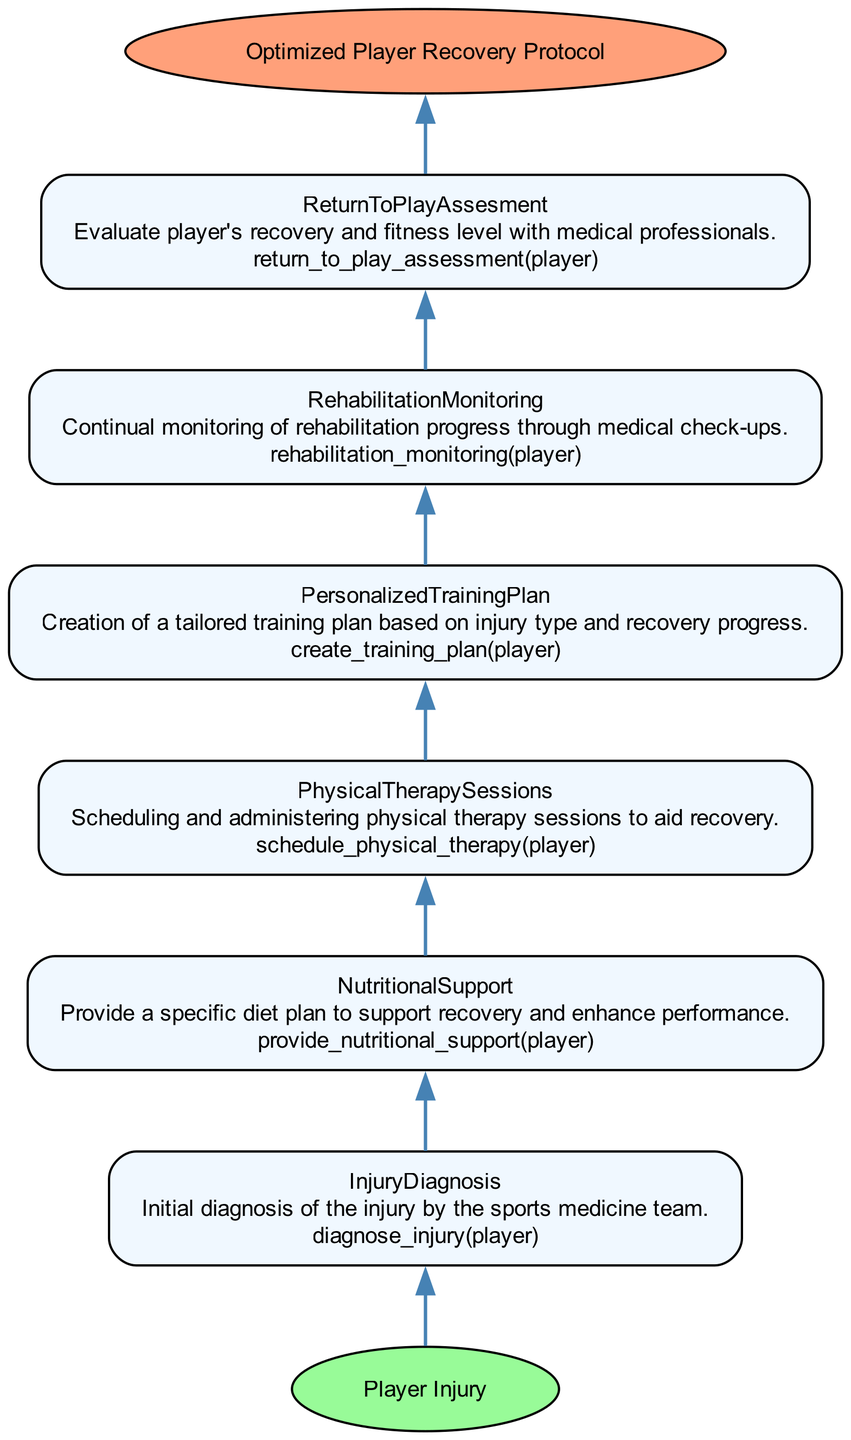What is the input for this diagram? The diagram starts with the input node, which is labeled "Player Injury." This is the first point from which the entire process begins.
Answer: Player Injury How many steps are included in the protocol? Counting the steps outlined in the diagram, we see a total of six distinct steps from diagnosis to return to play assessment.
Answer: 6 What does the last step in the diagram involve? The last step in the flow is labeled "ReturnToPlayAssesment," which is focused on evaluating the player's recovery and fitness level.
Answer: Evaluate player's recovery and fitness level What is the function associated with "PhysicalTherapySessions"? Each component in the diagram includes an associated function, and "PhysicalTherapySessions" corresponds to the function "schedule_physical_therapy(player)."
Answer: schedule_physical_therapy(player) Which step comes directly after "InjuryDiagnosis"? Looking at the flow order, "InjuryDiagnosis" is the first step, and the subsequent step is "PhysicalTherapySessions."
Answer: PhysicalTherapySessions What is the final output of the diagram? The end result concludes with the output node labeled "Optimized Player Recovery Protocol," which represents the achieved goal after following all the steps.
Answer: Optimized Player Recovery Protocol In which step is "NutritionalSupport" mentioned? By tracing through the diagram, "NutritionalSupport" is identified as the fourth step in the recovery protocol after "PhysicalTherapySessions."
Answer: The fourth step What happens after creating a personalized training plan? Following the current flow of the protocol, the step that occurs after "PersonalizedTrainingPlan" is "RehabilitationMonitoring," which involves continual monitoring of rehabilitation progress.
Answer: RehabilitationMonitoring How does one reach the output from "NutritionalSupport"? To reach the output, one would follow the flow from "NutritionalSupport" to "ReturnToPlayAssesment," and then finally to the "Optimized Player Recovery Protocol," moving through the remainder of the steps accordingly.
Answer: Through ReturnToPlayAssesment to Optimized Player Recovery Protocol 